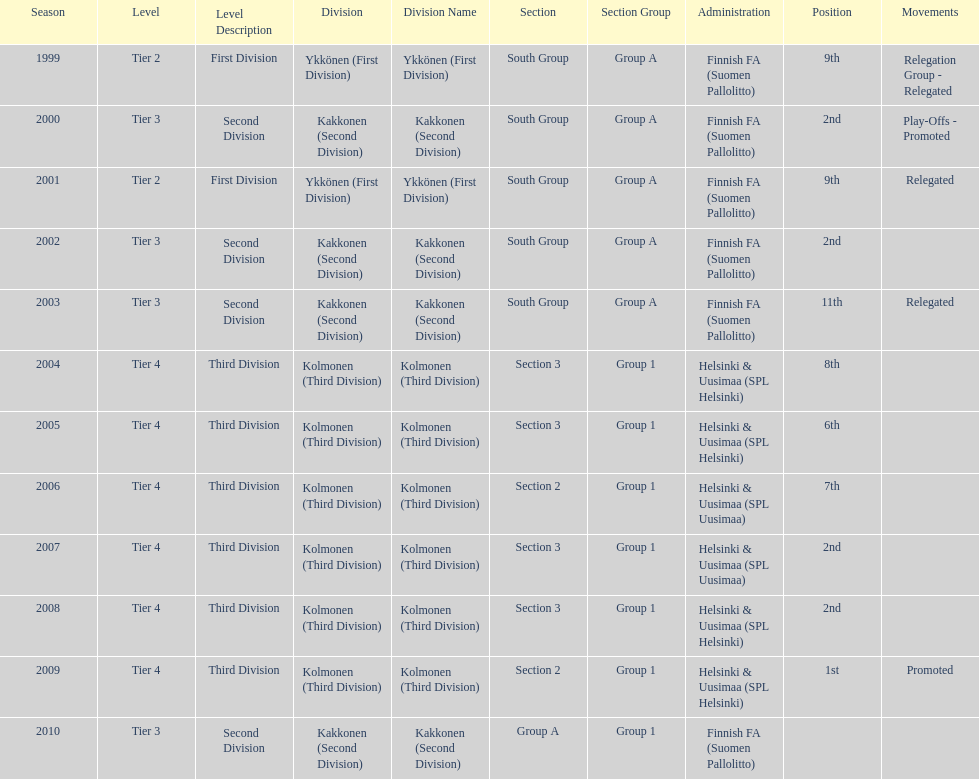Of the third division, how many were in section3? 4. Would you be able to parse every entry in this table? {'header': ['Season', 'Level', 'Level Description', 'Division', 'Division Name', 'Section', 'Section Group', 'Administration', 'Position', 'Movements'], 'rows': [['1999', 'Tier 2', 'First Division', 'Ykkönen (First Division)', 'Ykkönen (First Division)', 'South Group', 'Group A', 'Finnish FA (Suomen Pallolitto)', '9th', 'Relegation Group - Relegated'], ['2000', 'Tier 3', 'Second Division', 'Kakkonen (Second Division)', 'Kakkonen (Second Division)', 'South Group', 'Group A', 'Finnish FA (Suomen Pallolitto)', '2nd', 'Play-Offs - Promoted'], ['2001', 'Tier 2', 'First Division', 'Ykkönen (First Division)', 'Ykkönen (First Division)', 'South Group', 'Group A', 'Finnish FA (Suomen Pallolitto)', '9th', 'Relegated'], ['2002', 'Tier 3', 'Second Division', 'Kakkonen (Second Division)', 'Kakkonen (Second Division)', 'South Group', 'Group A', 'Finnish FA (Suomen Pallolitto)', '2nd', ''], ['2003', 'Tier 3', 'Second Division', 'Kakkonen (Second Division)', 'Kakkonen (Second Division)', 'South Group', 'Group A', 'Finnish FA (Suomen Pallolitto)', '11th', 'Relegated'], ['2004', 'Tier 4', 'Third Division', 'Kolmonen (Third Division)', 'Kolmonen (Third Division)', 'Section 3', 'Group 1', 'Helsinki & Uusimaa (SPL Helsinki)', '8th', ''], ['2005', 'Tier 4', 'Third Division', 'Kolmonen (Third Division)', 'Kolmonen (Third Division)', 'Section 3', 'Group 1', 'Helsinki & Uusimaa (SPL Helsinki)', '6th', ''], ['2006', 'Tier 4', 'Third Division', 'Kolmonen (Third Division)', 'Kolmonen (Third Division)', 'Section 2', 'Group 1', 'Helsinki & Uusimaa (SPL Uusimaa)', '7th', ''], ['2007', 'Tier 4', 'Third Division', 'Kolmonen (Third Division)', 'Kolmonen (Third Division)', 'Section 3', 'Group 1', 'Helsinki & Uusimaa (SPL Uusimaa)', '2nd', ''], ['2008', 'Tier 4', 'Third Division', 'Kolmonen (Third Division)', 'Kolmonen (Third Division)', 'Section 3', 'Group 1', 'Helsinki & Uusimaa (SPL Helsinki)', '2nd', ''], ['2009', 'Tier 4', 'Third Division', 'Kolmonen (Third Division)', 'Kolmonen (Third Division)', 'Section 2', 'Group 1', 'Helsinki & Uusimaa (SPL Helsinki)', '1st', 'Promoted'], ['2010', 'Tier 3', 'Second Division', 'Kakkonen (Second Division)', 'Kakkonen (Second Division)', 'Group A', 'Group 1', 'Finnish FA (Suomen Pallolitto)', '', '']]} 